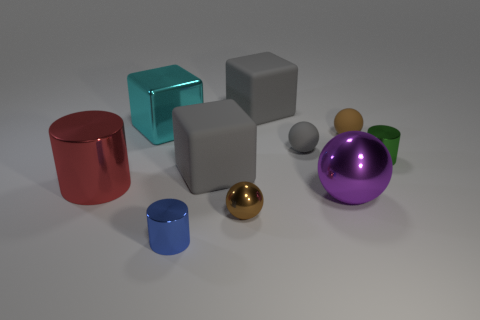Is there anything else that is the same color as the tiny shiny ball?
Your answer should be compact. Yes. There is a cylinder that is both on the right side of the large red cylinder and to the left of the tiny green object; what is its size?
Give a very brief answer. Small. Does the tiny metal ball have the same color as the tiny sphere behind the tiny gray rubber ball?
Provide a succinct answer. Yes. What number of purple objects are metal things or cylinders?
Provide a succinct answer. 1. What is the shape of the small gray object?
Offer a terse response. Sphere. How many other objects are there of the same shape as the purple object?
Give a very brief answer. 3. The tiny metallic cylinder left of the purple object is what color?
Make the answer very short. Blue. Are the tiny gray object and the green cylinder made of the same material?
Give a very brief answer. No. What number of things are large red shiny objects or objects that are in front of the red cylinder?
Your answer should be very brief. 4. There is a big metal thing in front of the large red cylinder; what is its shape?
Ensure brevity in your answer.  Sphere. 